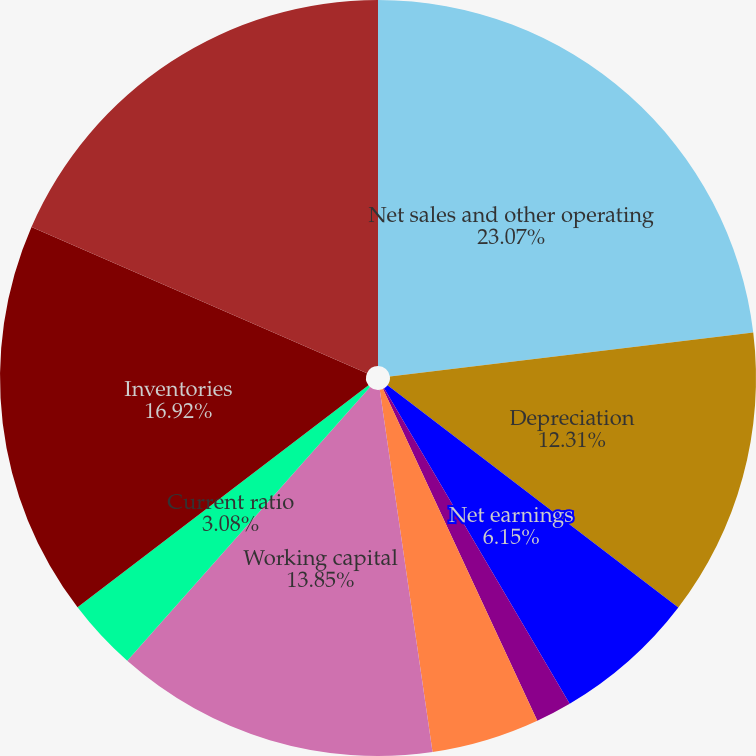<chart> <loc_0><loc_0><loc_500><loc_500><pie_chart><fcel>Net sales and other operating<fcel>Depreciation<fcel>Net earnings<fcel>Basic earnings per common<fcel>Cash dividends<fcel>Per common share<fcel>Working capital<fcel>Current ratio<fcel>Inventories<fcel>Net property plant and<nl><fcel>23.08%<fcel>12.31%<fcel>6.15%<fcel>1.54%<fcel>4.62%<fcel>0.0%<fcel>13.85%<fcel>3.08%<fcel>16.92%<fcel>18.46%<nl></chart> 